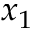Convert formula to latex. <formula><loc_0><loc_0><loc_500><loc_500>x _ { 1 }</formula> 